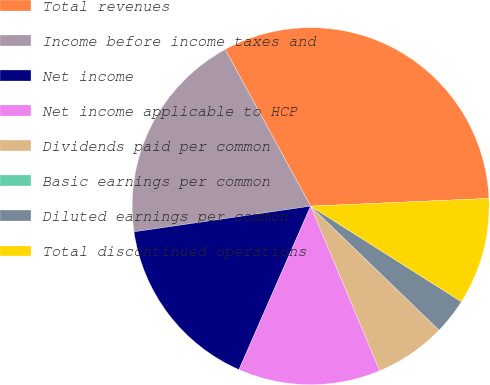Convert chart to OTSL. <chart><loc_0><loc_0><loc_500><loc_500><pie_chart><fcel>Total revenues<fcel>Income before income taxes and<fcel>Net income<fcel>Net income applicable to HCP<fcel>Dividends paid per common<fcel>Basic earnings per common<fcel>Diluted earnings per common<fcel>Total discontinued operations<nl><fcel>32.26%<fcel>19.35%<fcel>16.13%<fcel>12.9%<fcel>6.45%<fcel>0.0%<fcel>3.23%<fcel>9.68%<nl></chart> 